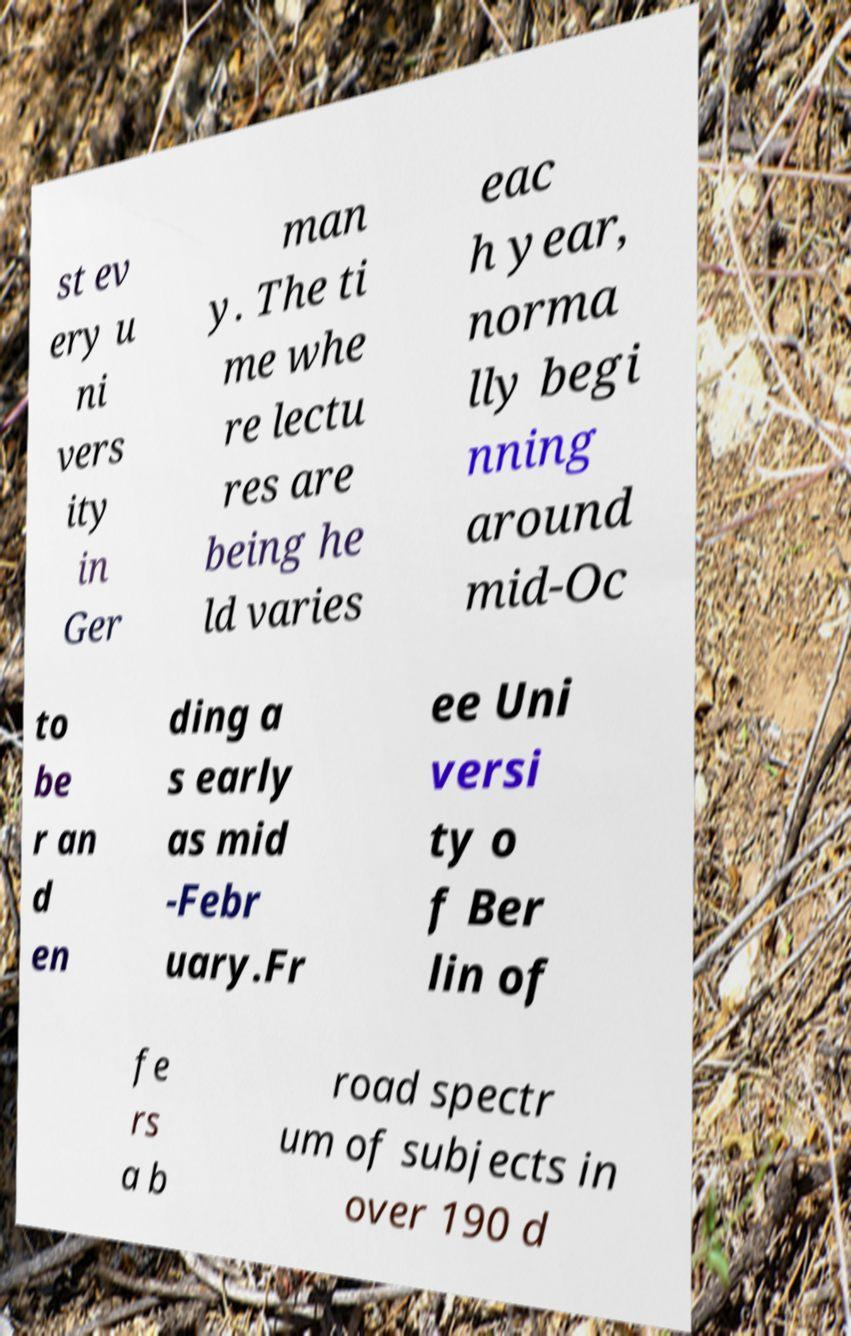Can you read and provide the text displayed in the image?This photo seems to have some interesting text. Can you extract and type it out for me? st ev ery u ni vers ity in Ger man y. The ti me whe re lectu res are being he ld varies eac h year, norma lly begi nning around mid-Oc to be r an d en ding a s early as mid -Febr uary.Fr ee Uni versi ty o f Ber lin of fe rs a b road spectr um of subjects in over 190 d 